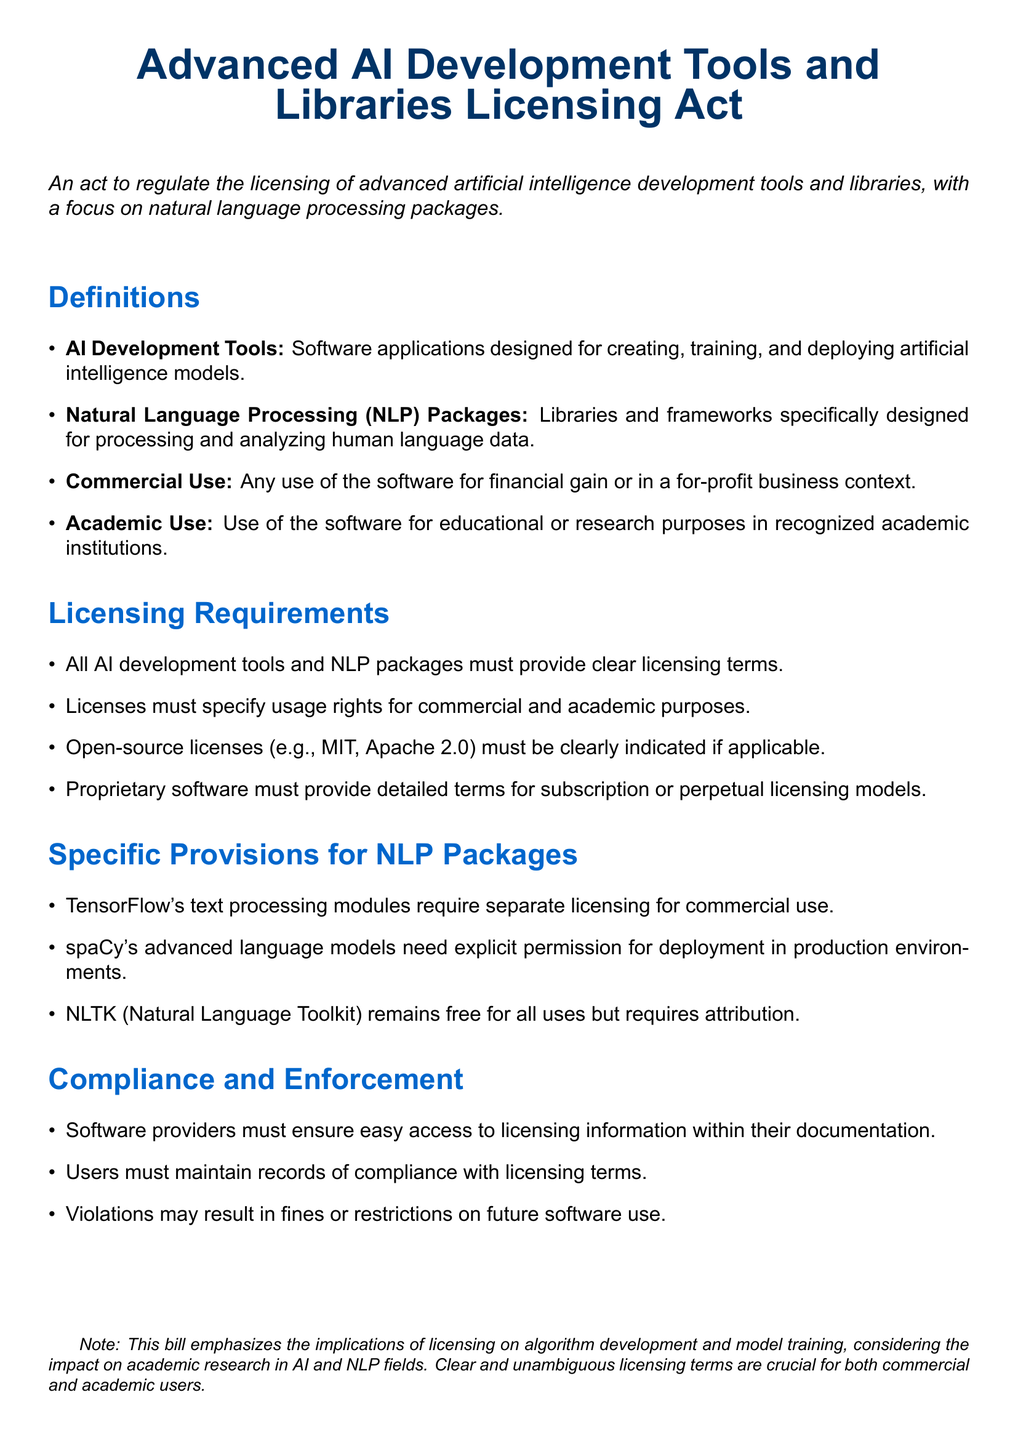What is the title of the bill? The title of the bill is found at the top of the document, highlighting its focus on AI development tools and libraries.
Answer: Advanced AI Development Tools and Libraries Licensing Act What are AI Development Tools? The document provides a definition of AI Development Tools in the definitions section.
Answer: Software applications designed for creating, training, and deploying artificial intelligence models Which library requires separate licensing for commercial use? The specific provisions section mentions which library has this requirement.
Answer: TensorFlow Is NLTK free for all uses? The document explicitly states the licensing terms for NLTK in the specific provisions section.
Answer: Yes What may happen in case of licensing violations? The compliance and enforcement section outlines the consequences of not adhering to licensing terms.
Answer: Fines or restrictions on future software use 